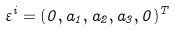<formula> <loc_0><loc_0><loc_500><loc_500>\varepsilon ^ { i } = ( 0 , a _ { 1 } , a _ { 2 } , a _ { 3 } , 0 ) ^ { T }</formula> 